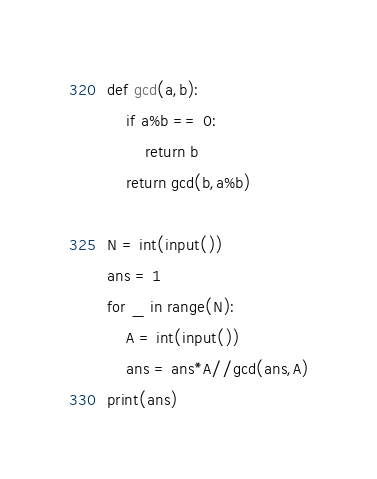<code> <loc_0><loc_0><loc_500><loc_500><_Python_>def gcd(a,b):
    if a%b == 0:
        return b
    return gcd(b,a%b)

N = int(input())
ans = 1
for _ in range(N):
    A = int(input())
    ans = ans*A//gcd(ans,A)
print(ans)</code> 